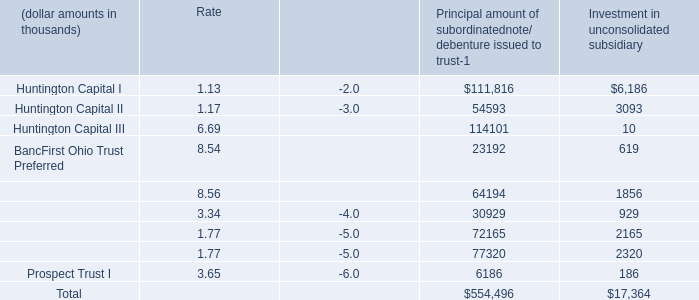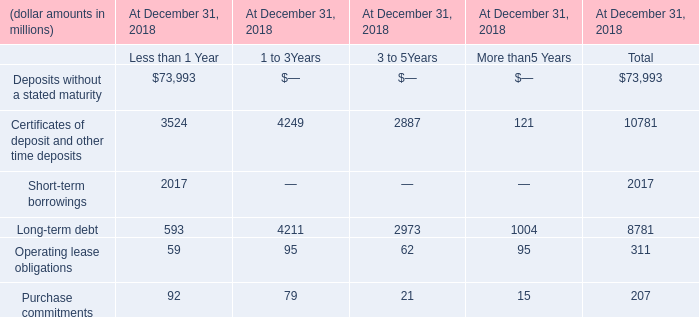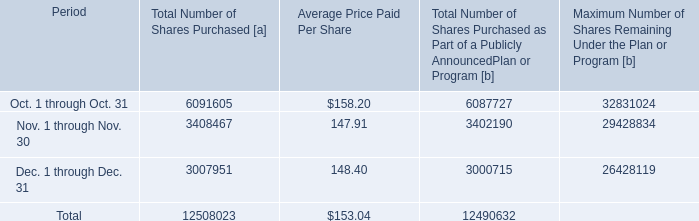What was the total amount of the Sky Financial Capital Trust I in the sections where Huntington Capital I greater than 10? (in thousand) 
Computations: (64194 + 1856)
Answer: 66050.0. 